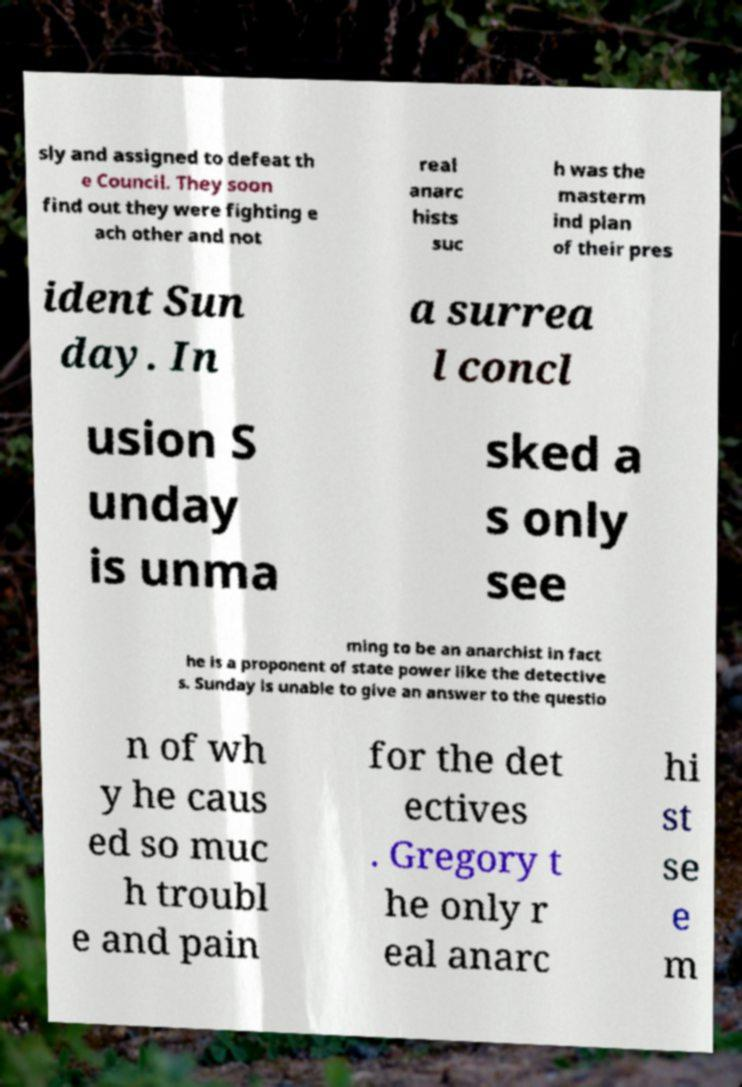Please identify and transcribe the text found in this image. sly and assigned to defeat th e Council. They soon find out they were fighting e ach other and not real anarc hists suc h was the masterm ind plan of their pres ident Sun day. In a surrea l concl usion S unday is unma sked a s only see ming to be an anarchist in fact he is a proponent of state power like the detective s. Sunday is unable to give an answer to the questio n of wh y he caus ed so muc h troubl e and pain for the det ectives . Gregory t he only r eal anarc hi st se e m 